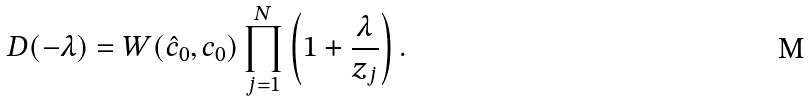<formula> <loc_0><loc_0><loc_500><loc_500>D ( - \lambda ) = W ( \hat { c } _ { 0 } , c _ { 0 } ) \prod _ { j = 1 } ^ { N } \left ( 1 + \frac { \lambda } { z _ { j } } \right ) .</formula> 